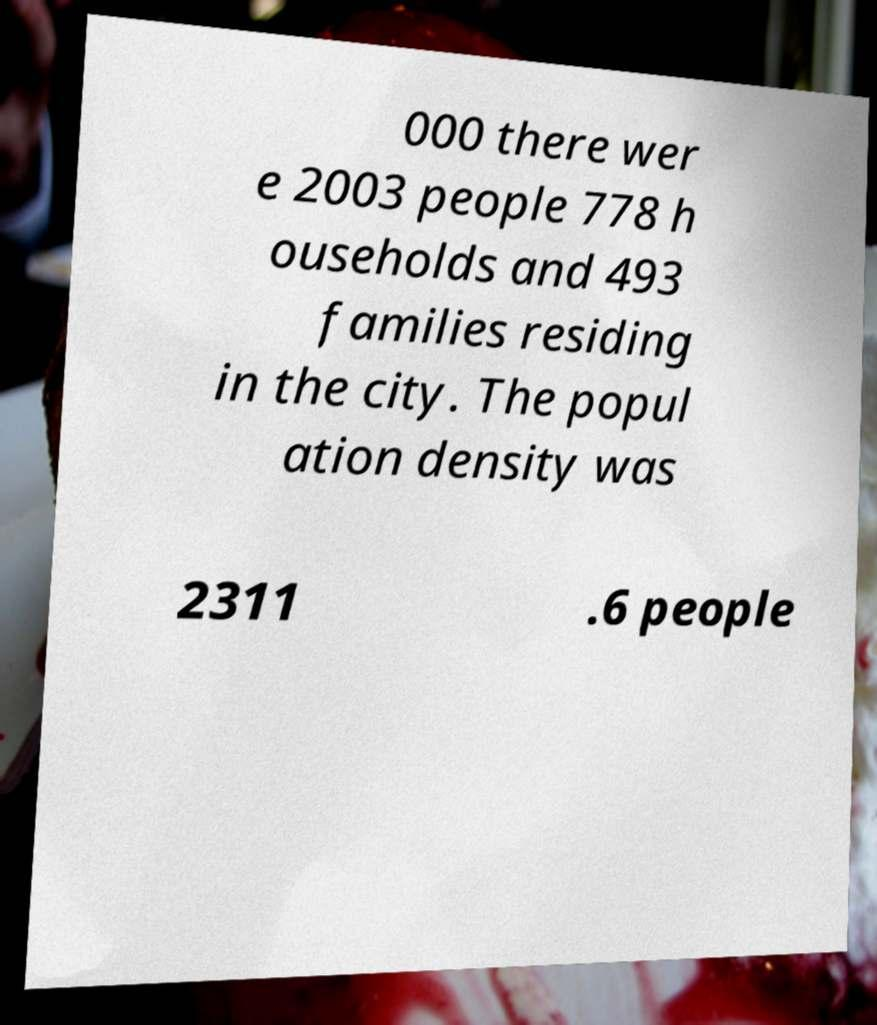Can you accurately transcribe the text from the provided image for me? 000 there wer e 2003 people 778 h ouseholds and 493 families residing in the city. The popul ation density was 2311 .6 people 